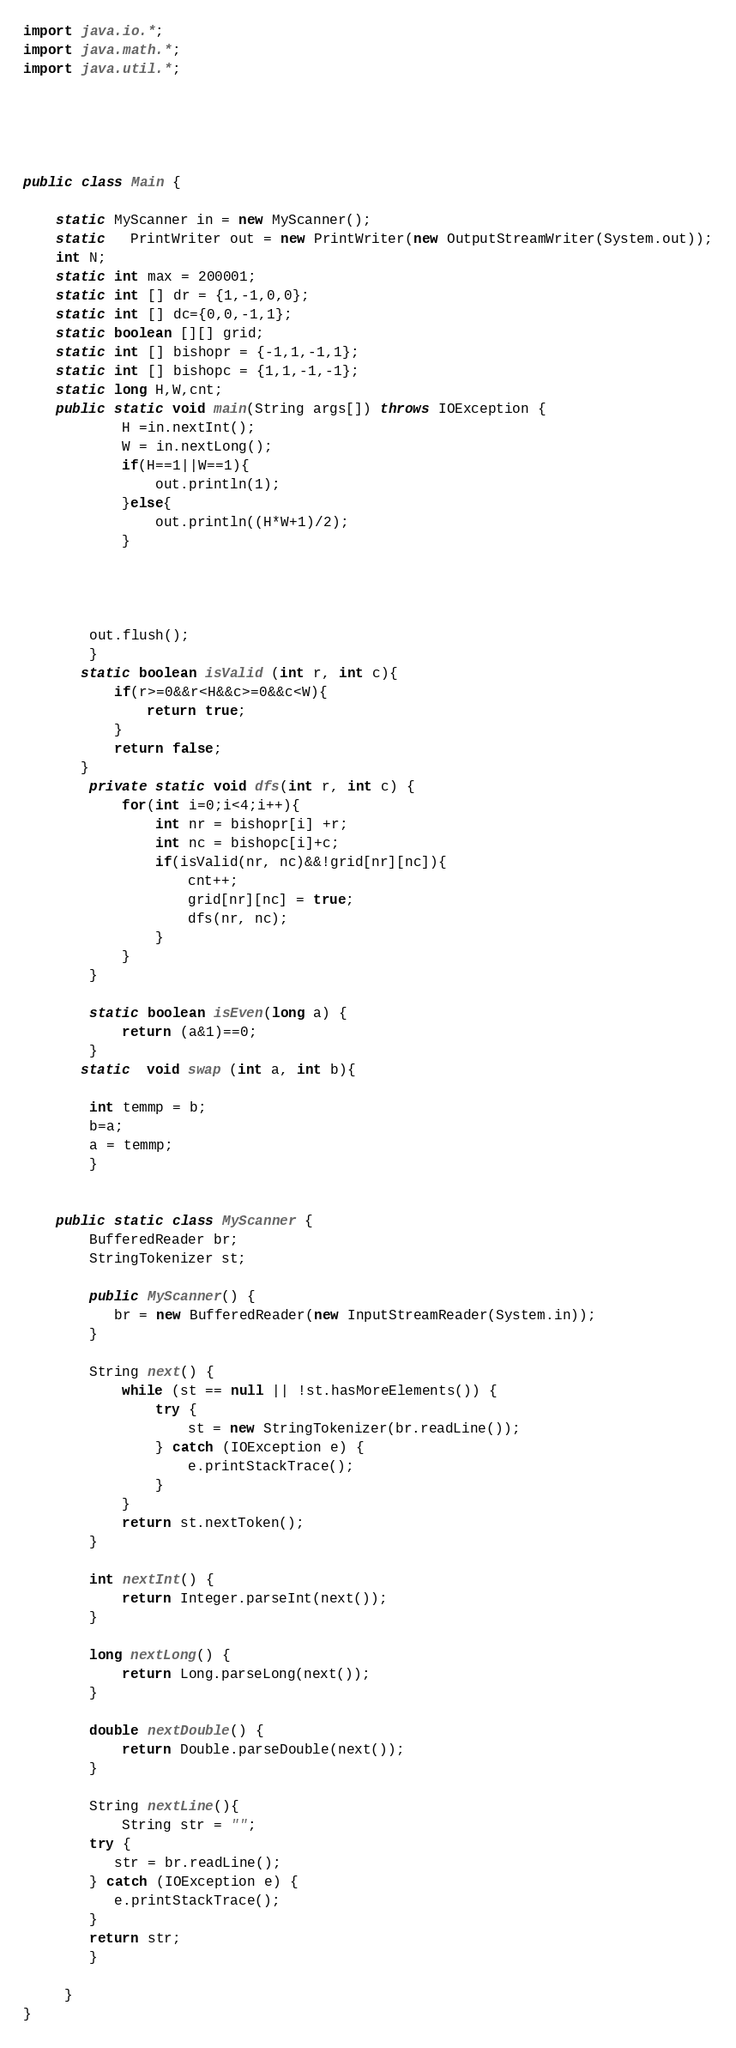Convert code to text. <code><loc_0><loc_0><loc_500><loc_500><_Java_>import java.io.*;
import java.math.*;
import java.util.*;





public class Main {

    static MyScanner in = new MyScanner();
    static   PrintWriter out = new PrintWriter(new OutputStreamWriter(System.out));
    int N;
    static int max = 200001;
    static int [] dr = {1,-1,0,0};
    static int [] dc={0,0,-1,1};
    static boolean [][] grid;
    static int [] bishopr = {-1,1,-1,1};
    static int [] bishopc = {1,1,-1,-1};
    static long H,W,cnt;
    public static void main(String args[]) throws IOException {
            H =in.nextInt();
            W = in.nextLong();
            if(H==1||W==1){
                out.println(1);
            }else{
                out.println((H*W+1)/2);
            }
        



        out.flush();
        }
       static boolean isValid (int r, int c){
           if(r>=0&&r<H&&c>=0&&c<W){
               return true;
           }
           return false;
       }
        private static void dfs(int r, int c) {
            for(int i=0;i<4;i++){
                int nr = bishopr[i] +r;
                int nc = bishopc[i]+c;
                if(isValid(nr, nc)&&!grid[nr][nc]){
                    cnt++;
                    grid[nr][nc] = true;
                    dfs(nr, nc);
                }
            }
        }

        static boolean isEven(long a) {
            return (a&1)==0;
        }
       static  void swap (int a, int b){

        int temmp = b;
        b=a;
        a = temmp;
        }
    

    public static class MyScanner {
        BufferedReader br;
        StringTokenizer st;
   
        public MyScanner() {
           br = new BufferedReader(new InputStreamReader(System.in));
        }
   
        String next() {
            while (st == null || !st.hasMoreElements()) {
                try {
                    st = new StringTokenizer(br.readLine());
                } catch (IOException e) {
                    e.printStackTrace();
                }
            }
            return st.nextToken();
        }
   
        int nextInt() {
            return Integer.parseInt(next());
        }
   
        long nextLong() {
            return Long.parseLong(next());
        }
   
        double nextDouble() {
            return Double.parseDouble(next());
        }
   
        String nextLine(){
            String str = "";
        try {
           str = br.readLine();
        } catch (IOException e) {
           e.printStackTrace();
        }
        return str;
        }
  
     }
}</code> 